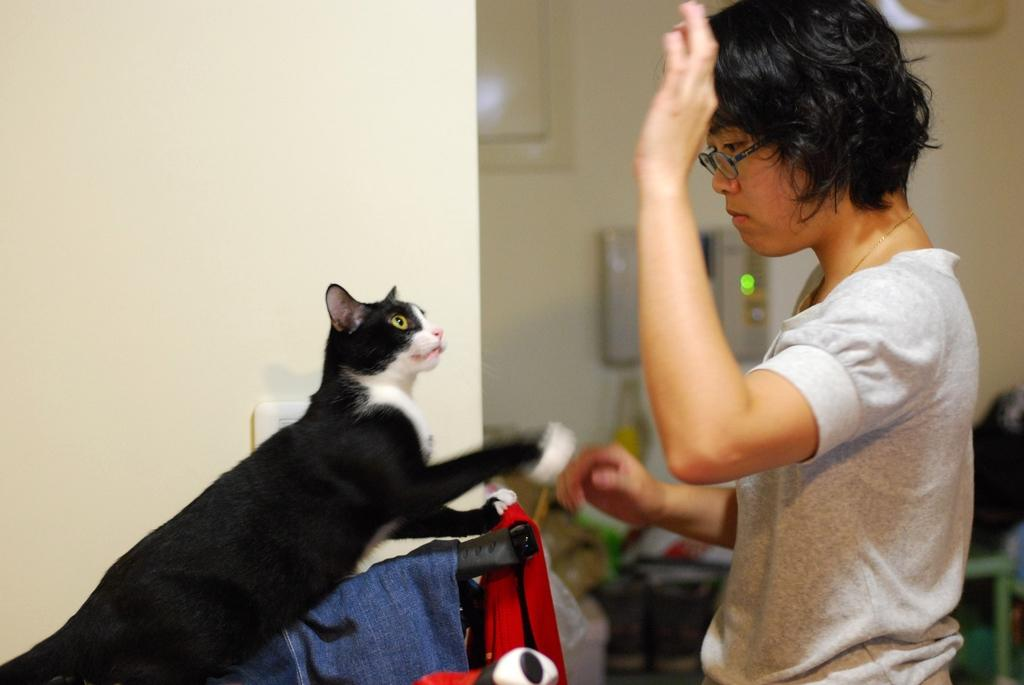Who is present in the image? There is a woman in the image. What is the woman doing in the image? The woman is standing in the image. What other living creature can be seen in the image? There is a cat in the image. What type of objects can be seen in the image? Clothes are visible in the image. What type of structure is present in the image? There is a wall in the image. How would you describe the background of the image? The background of the image is blurred. What type of knowledge is the woman sharing with the vase in the image? There is no vase present in the image, and therefore no such interaction can be observed. 